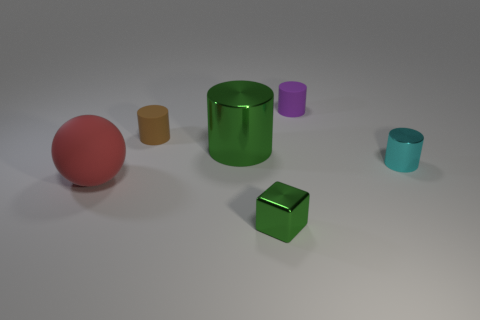Add 4 red matte spheres. How many objects exist? 10 Subtract all balls. How many objects are left? 5 Subtract 1 brown cylinders. How many objects are left? 5 Subtract all small green metal objects. Subtract all large red spheres. How many objects are left? 4 Add 2 large red things. How many large red things are left? 3 Add 4 small purple rubber objects. How many small purple rubber objects exist? 5 